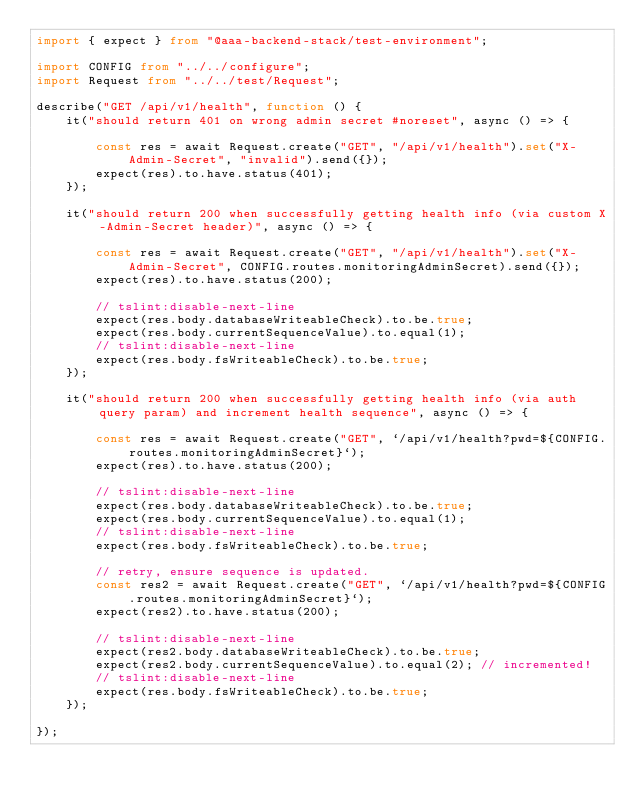<code> <loc_0><loc_0><loc_500><loc_500><_TypeScript_>import { expect } from "@aaa-backend-stack/test-environment";

import CONFIG from "../../configure";
import Request from "../../test/Request";

describe("GET /api/v1/health", function () {
    it("should return 401 on wrong admin secret #noreset", async () => {

        const res = await Request.create("GET", "/api/v1/health").set("X-Admin-Secret", "invalid").send({});
        expect(res).to.have.status(401);
    });

    it("should return 200 when successfully getting health info (via custom X-Admin-Secret header)", async () => {

        const res = await Request.create("GET", "/api/v1/health").set("X-Admin-Secret", CONFIG.routes.monitoringAdminSecret).send({});
        expect(res).to.have.status(200);

        // tslint:disable-next-line
        expect(res.body.databaseWriteableCheck).to.be.true;
        expect(res.body.currentSequenceValue).to.equal(1);
        // tslint:disable-next-line
        expect(res.body.fsWriteableCheck).to.be.true;
    });

    it("should return 200 when successfully getting health info (via auth query param) and increment health sequence", async () => {

        const res = await Request.create("GET", `/api/v1/health?pwd=${CONFIG.routes.monitoringAdminSecret}`);
        expect(res).to.have.status(200);

        // tslint:disable-next-line
        expect(res.body.databaseWriteableCheck).to.be.true;
        expect(res.body.currentSequenceValue).to.equal(1);
        // tslint:disable-next-line
        expect(res.body.fsWriteableCheck).to.be.true;

        // retry, ensure sequence is updated.
        const res2 = await Request.create("GET", `/api/v1/health?pwd=${CONFIG.routes.monitoringAdminSecret}`);
        expect(res2).to.have.status(200);

        // tslint:disable-next-line
        expect(res2.body.databaseWriteableCheck).to.be.true;
        expect(res2.body.currentSequenceValue).to.equal(2); // incremented!
        // tslint:disable-next-line
        expect(res.body.fsWriteableCheck).to.be.true;
    });

});
</code> 